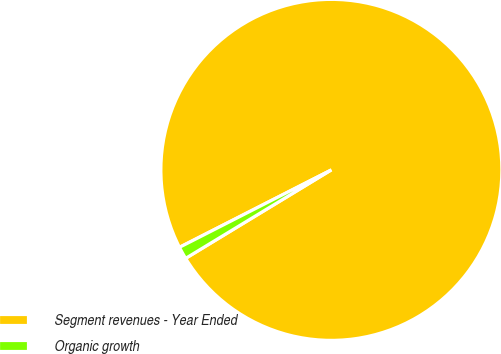Convert chart to OTSL. <chart><loc_0><loc_0><loc_500><loc_500><pie_chart><fcel>Segment revenues - Year Ended<fcel>Organic growth<nl><fcel>98.82%<fcel>1.18%<nl></chart> 